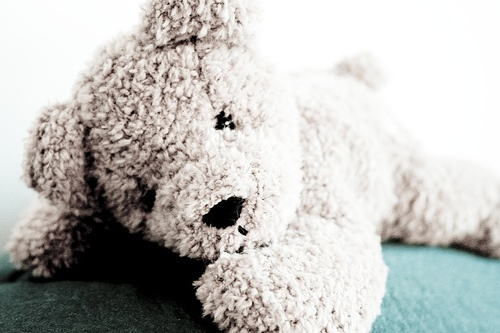Describe the objects in this image and their specific colors. I can see a teddy bear in white, darkgray, and black tones in this image. 